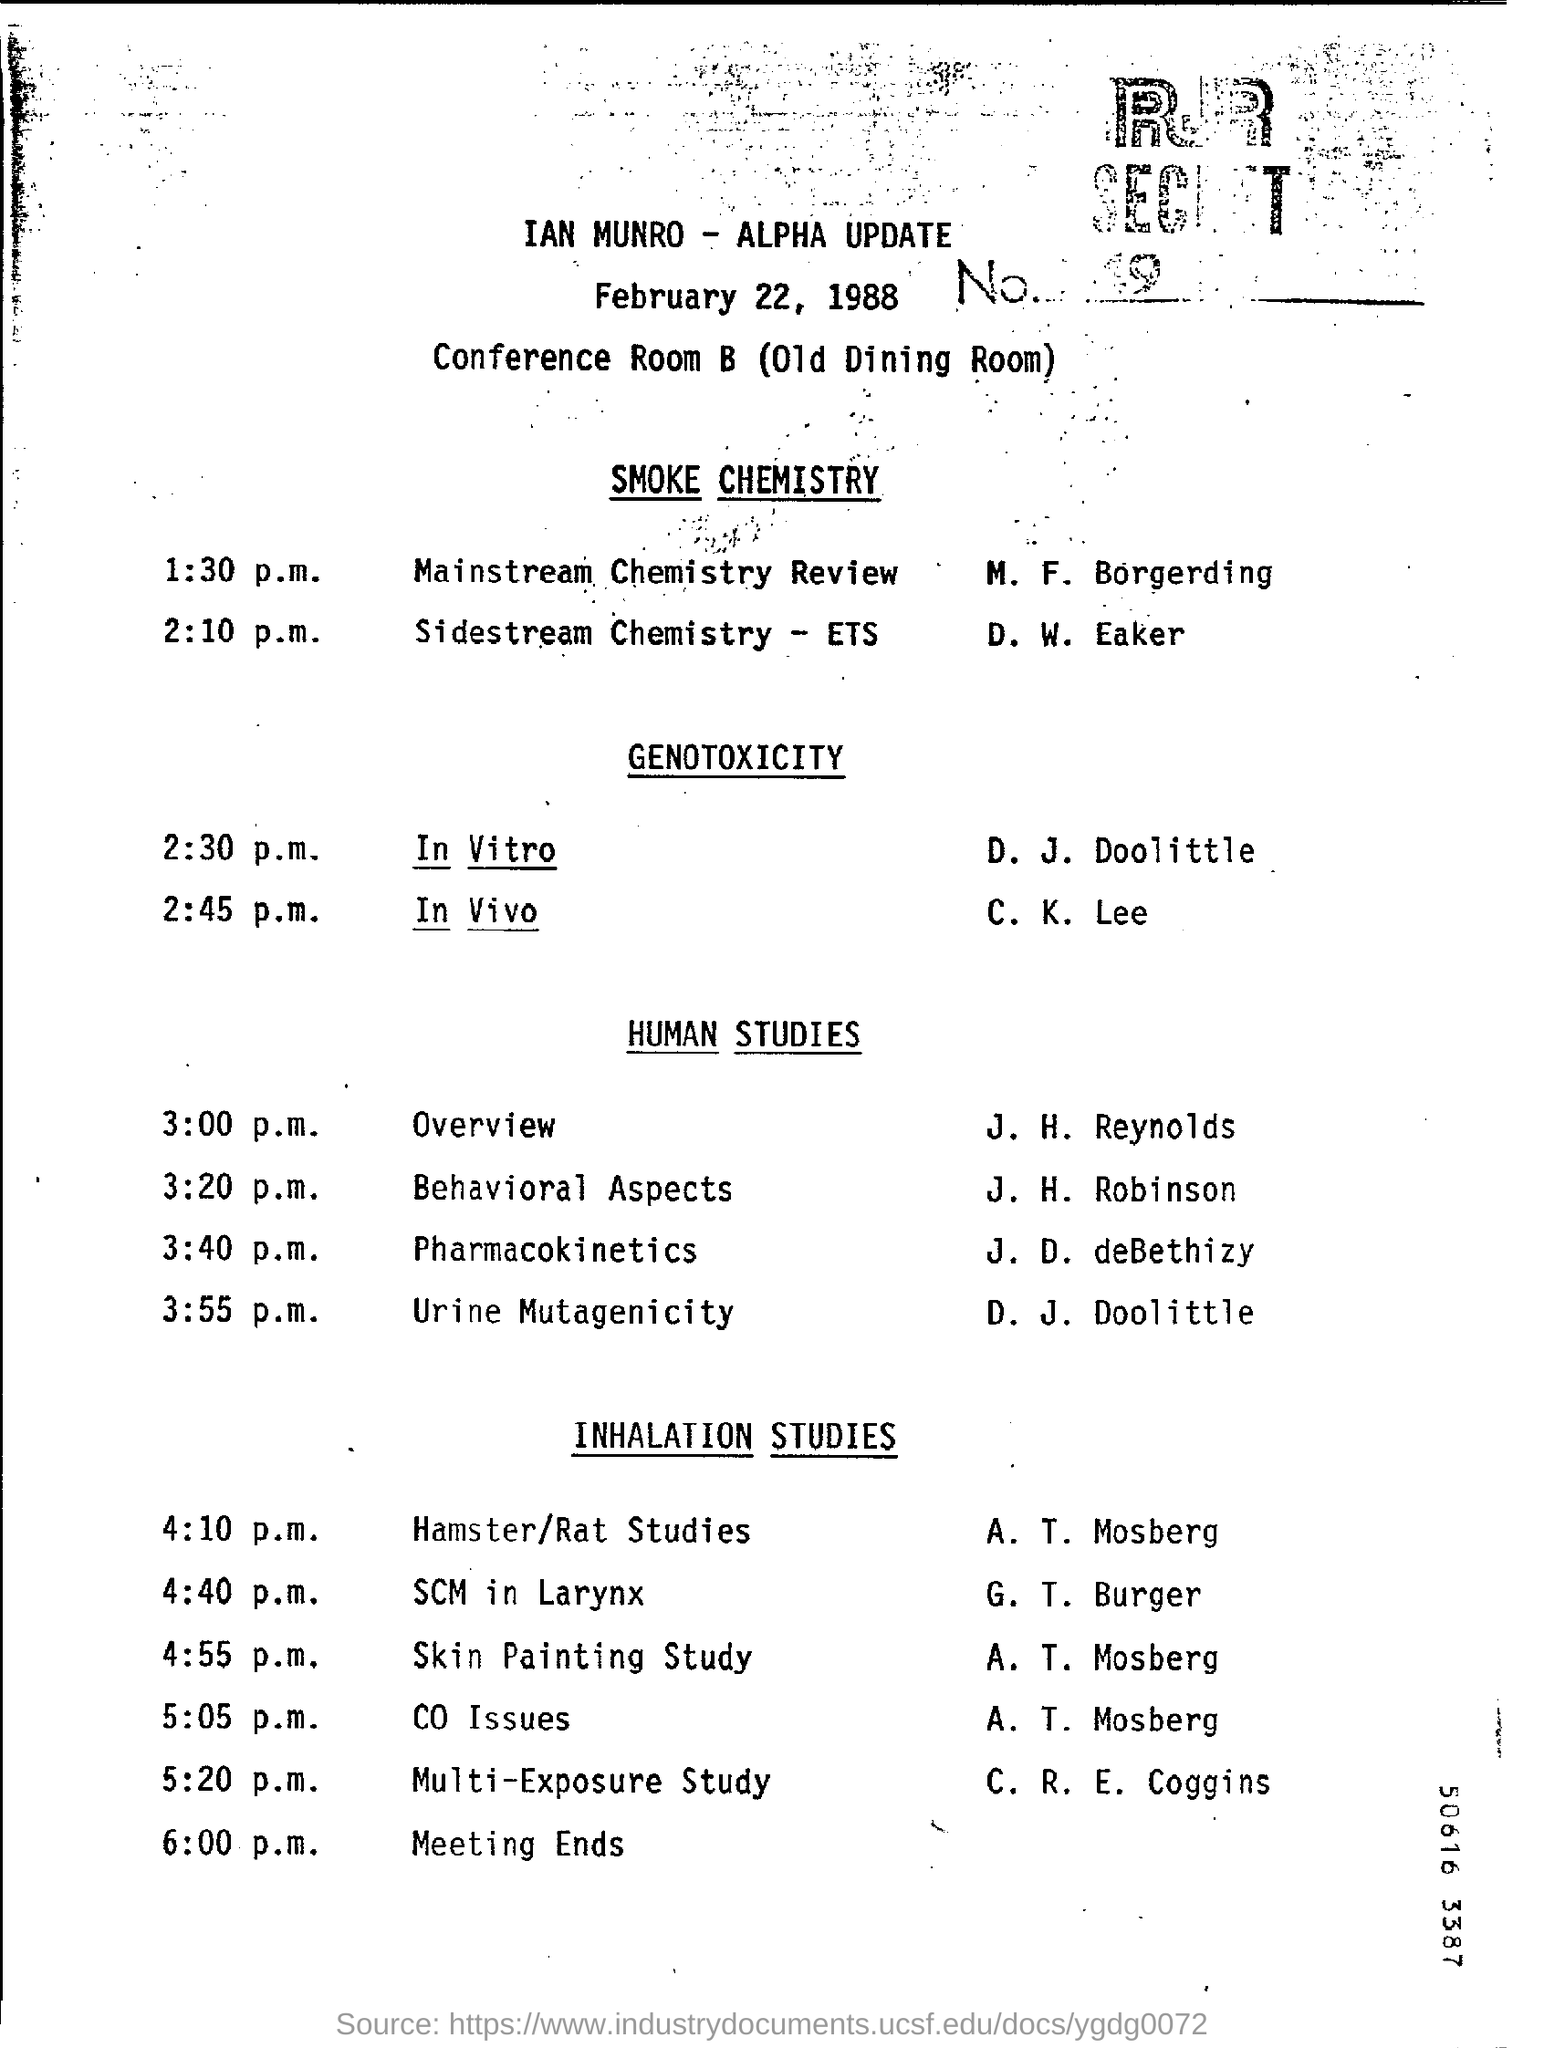Indicate a few pertinent items in this graphic. The date mentioned at the top of the document is February 22, 1988. 